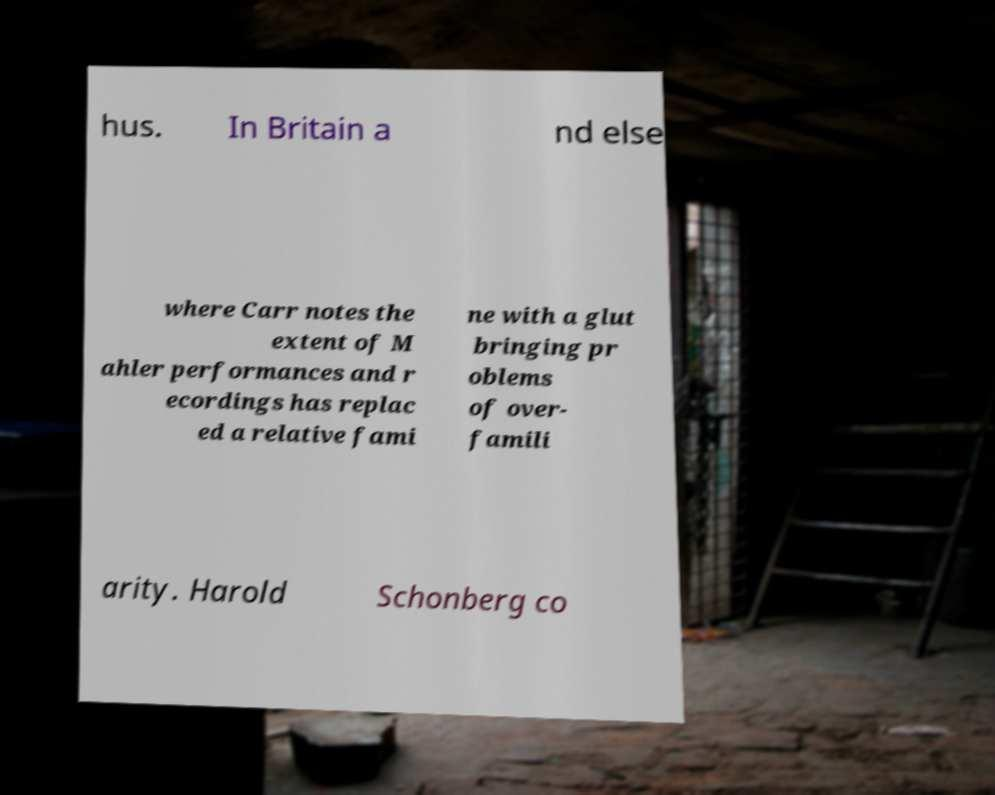For documentation purposes, I need the text within this image transcribed. Could you provide that? hus. In Britain a nd else where Carr notes the extent of M ahler performances and r ecordings has replac ed a relative fami ne with a glut bringing pr oblems of over- famili arity. Harold Schonberg co 